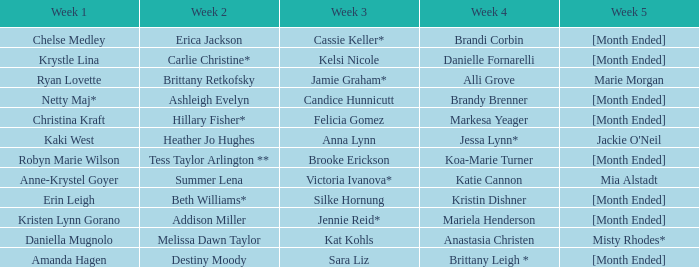What does week 1 entail with candice hunnicutt during week 3? Netty Maj*. 